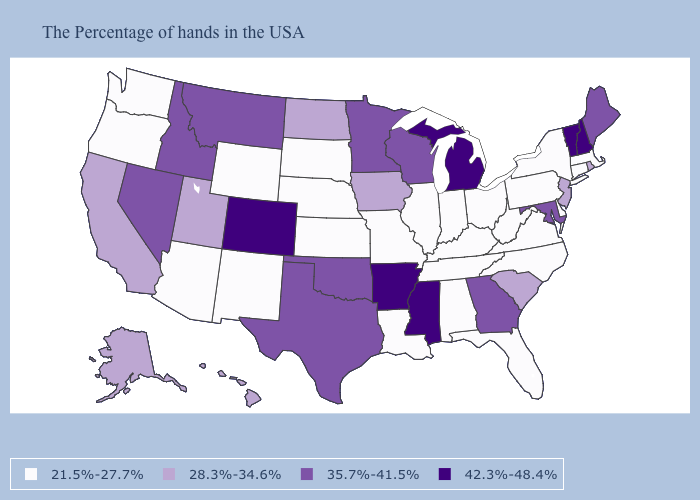What is the value of Iowa?
Quick response, please. 28.3%-34.6%. Name the states that have a value in the range 42.3%-48.4%?
Short answer required. New Hampshire, Vermont, Michigan, Mississippi, Arkansas, Colorado. What is the value of Pennsylvania?
Write a very short answer. 21.5%-27.7%. What is the value of New York?
Answer briefly. 21.5%-27.7%. What is the value of Delaware?
Quick response, please. 21.5%-27.7%. What is the value of Kentucky?
Concise answer only. 21.5%-27.7%. What is the highest value in states that border Rhode Island?
Concise answer only. 21.5%-27.7%. What is the value of Iowa?
Concise answer only. 28.3%-34.6%. What is the value of Idaho?
Answer briefly. 35.7%-41.5%. Name the states that have a value in the range 35.7%-41.5%?
Answer briefly. Maine, Maryland, Georgia, Wisconsin, Minnesota, Oklahoma, Texas, Montana, Idaho, Nevada. Which states have the highest value in the USA?
Keep it brief. New Hampshire, Vermont, Michigan, Mississippi, Arkansas, Colorado. Among the states that border Ohio , which have the highest value?
Give a very brief answer. Michigan. What is the value of Massachusetts?
Be succinct. 21.5%-27.7%. 